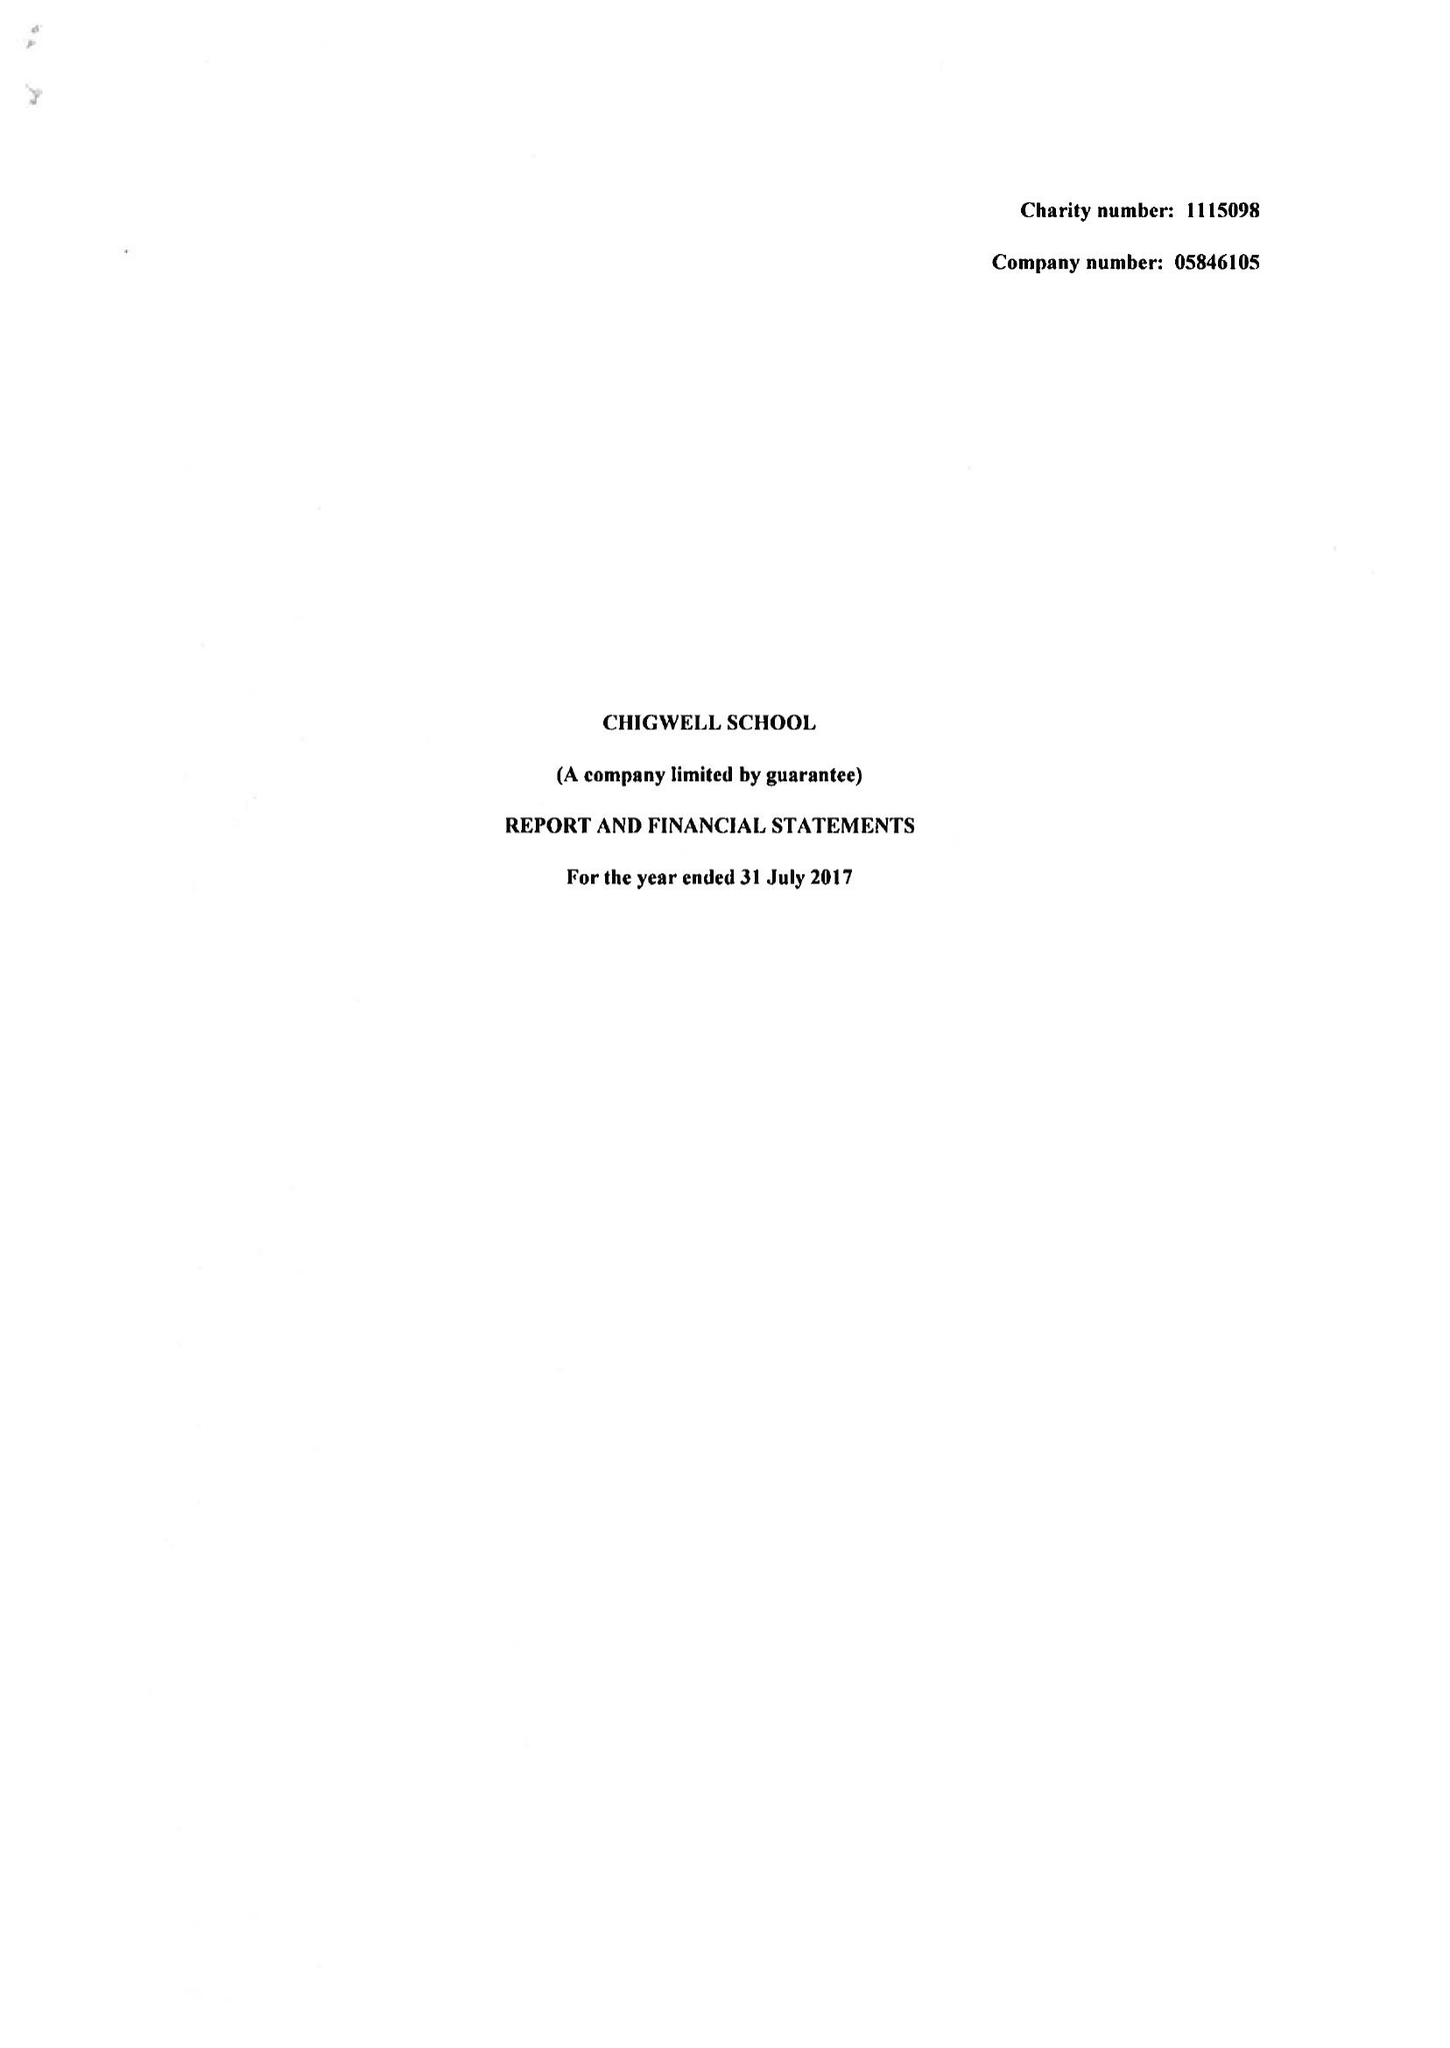What is the value for the income_annually_in_british_pounds?
Answer the question using a single word or phrase. 13765957.00 